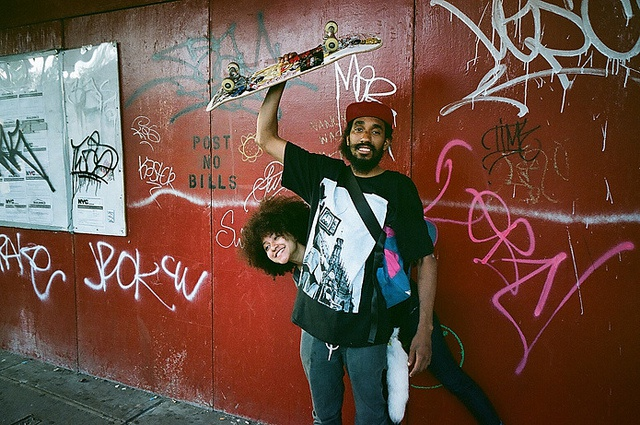Describe the objects in this image and their specific colors. I can see people in black, lightgray, teal, and gray tones, people in black, tan, olive, and gray tones, handbag in black, blue, teal, and violet tones, skateboard in black, lightgray, darkgray, and gray tones, and backpack in black, blue, teal, and violet tones in this image. 